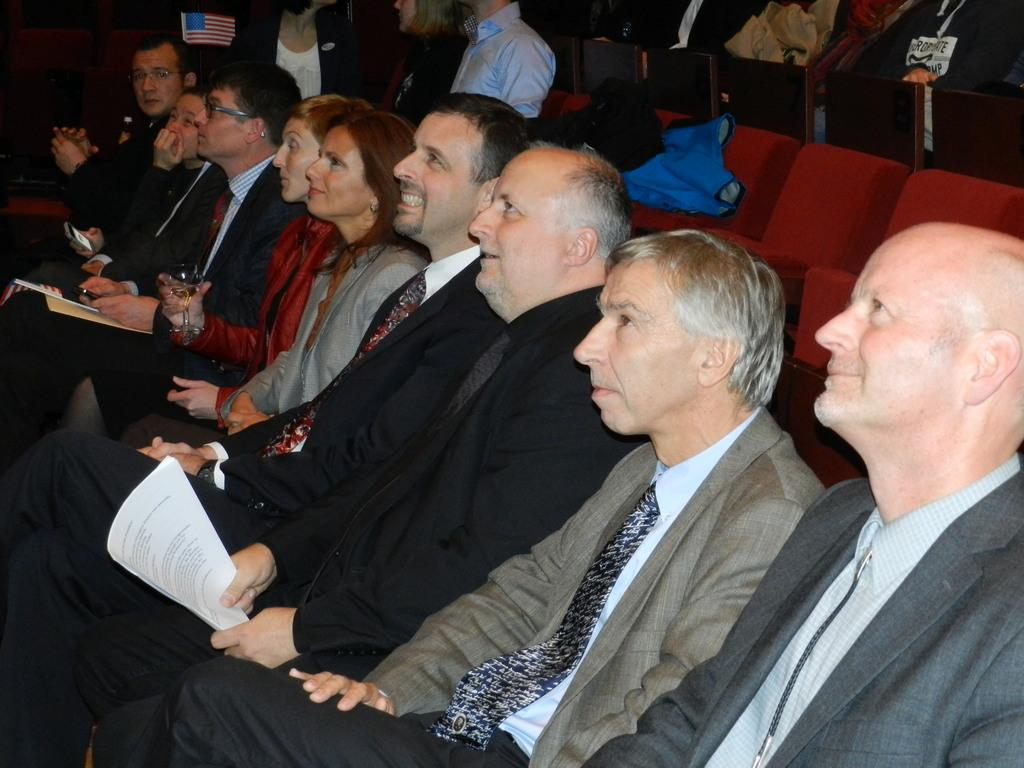How many people are in the image? There are people in the image, but the exact number is not specified. What are some of the people in the image doing? Some people are sitting in the image. What can be seen in the background of the image? There are seats and objects in the background of the image. What are some people holding in the image? Some people are holding objects in the image. How many pizzas are being served to the people in the image? There is no mention of pizzas in the image, so we cannot determine how many are being served. 